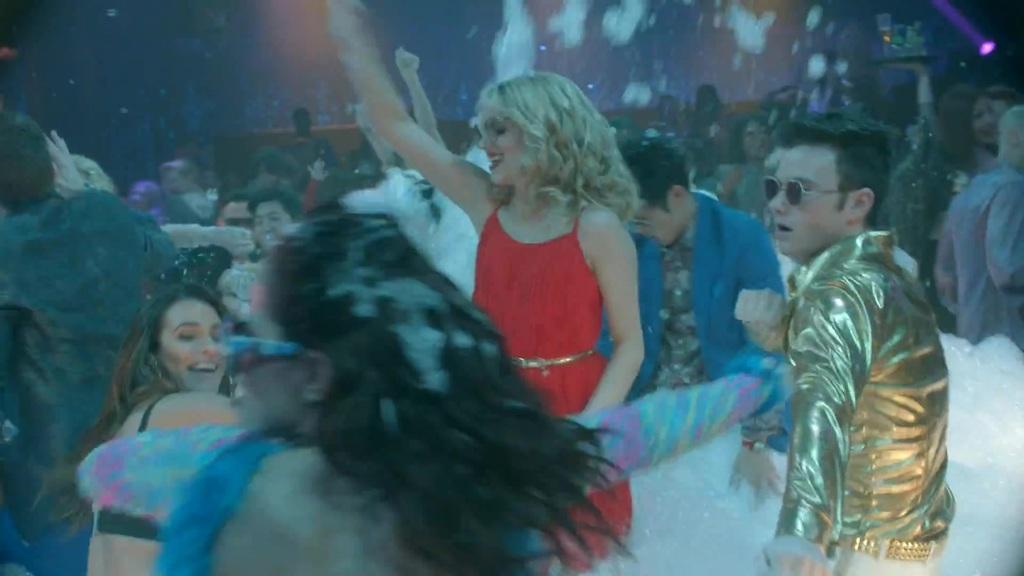Can you describe this image briefly? In this image there are group of people dancing, and in the background there are some objects. 